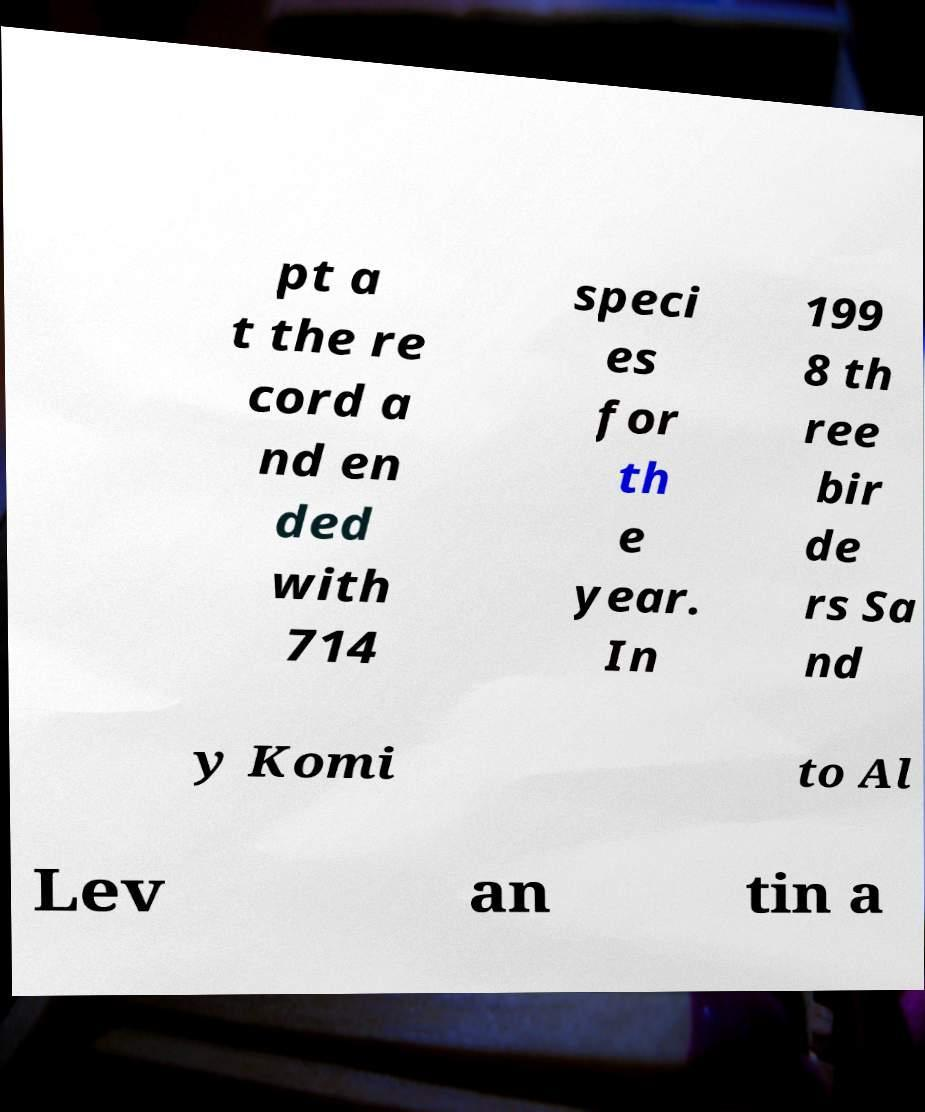Could you assist in decoding the text presented in this image and type it out clearly? pt a t the re cord a nd en ded with 714 speci es for th e year. In 199 8 th ree bir de rs Sa nd y Komi to Al Lev an tin a 